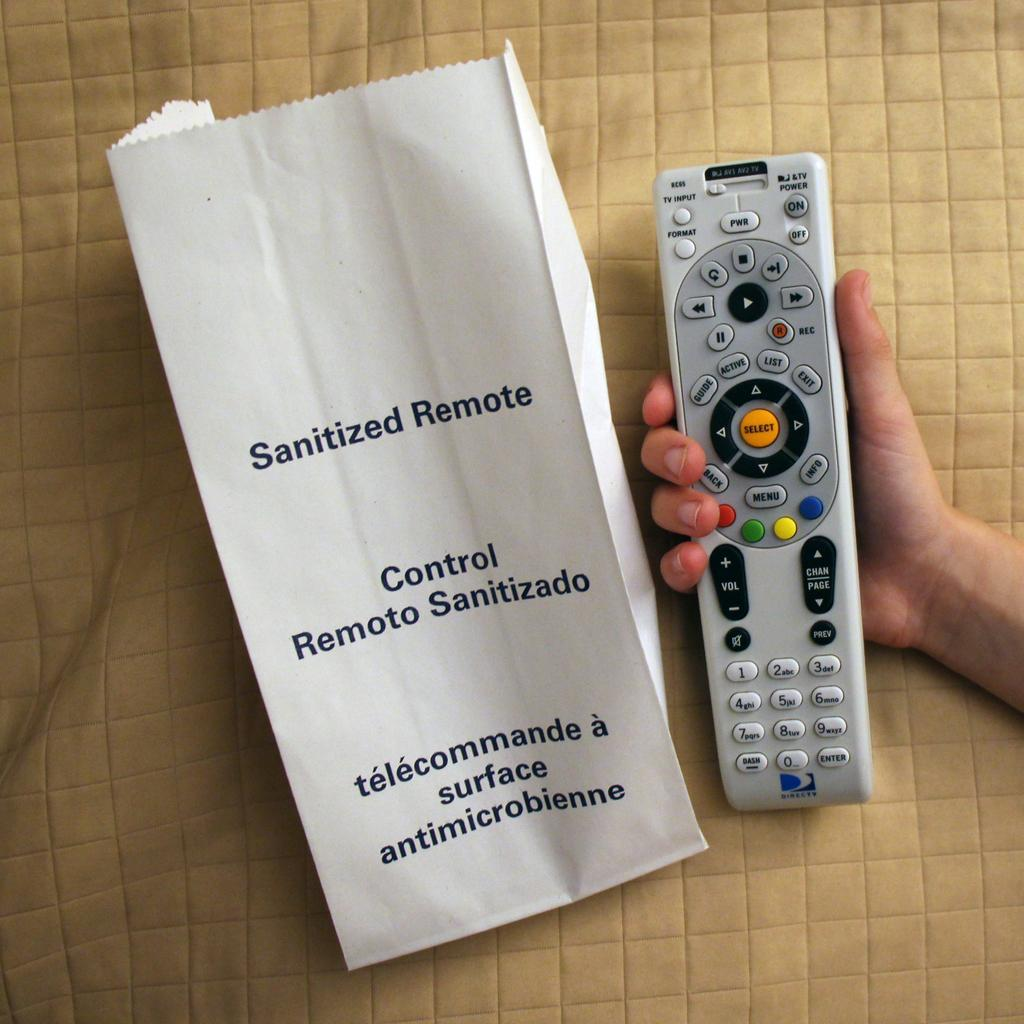Provide a one-sentence caption for the provided image. A person holding a remote and a paper bag beside it that says Sanitized Remote. 